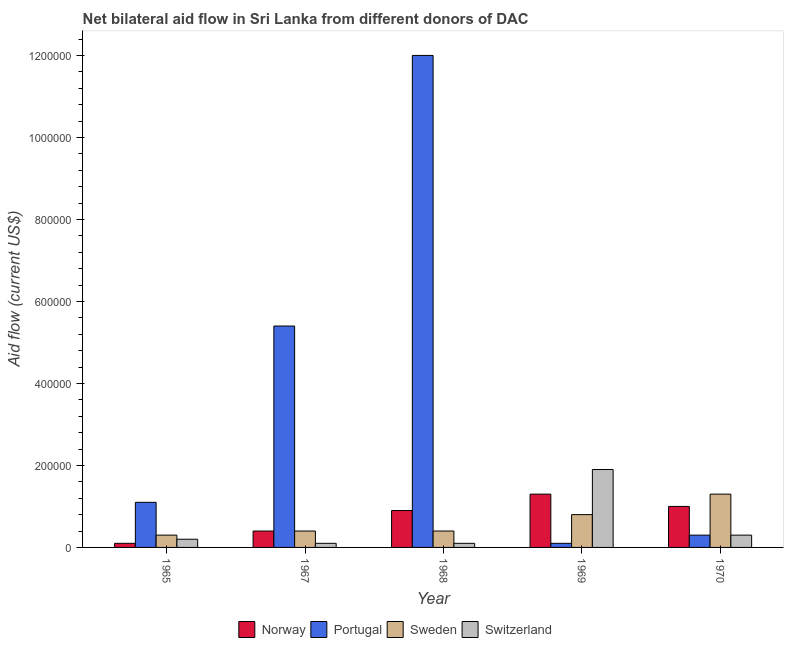How many different coloured bars are there?
Offer a terse response. 4. How many groups of bars are there?
Offer a terse response. 5. Are the number of bars on each tick of the X-axis equal?
Ensure brevity in your answer.  Yes. How many bars are there on the 1st tick from the left?
Keep it short and to the point. 4. What is the label of the 3rd group of bars from the left?
Your answer should be compact. 1968. In how many cases, is the number of bars for a given year not equal to the number of legend labels?
Give a very brief answer. 0. What is the amount of aid given by portugal in 1969?
Your response must be concise. 10000. Across all years, what is the maximum amount of aid given by norway?
Make the answer very short. 1.30e+05. Across all years, what is the minimum amount of aid given by switzerland?
Keep it short and to the point. 10000. In which year was the amount of aid given by switzerland maximum?
Keep it short and to the point. 1969. In which year was the amount of aid given by sweden minimum?
Provide a short and direct response. 1965. What is the total amount of aid given by portugal in the graph?
Make the answer very short. 1.89e+06. What is the difference between the amount of aid given by switzerland in 1965 and that in 1967?
Provide a succinct answer. 10000. What is the difference between the amount of aid given by sweden in 1967 and the amount of aid given by portugal in 1970?
Provide a short and direct response. -9.00e+04. What is the average amount of aid given by portugal per year?
Your answer should be very brief. 3.78e+05. In the year 1965, what is the difference between the amount of aid given by sweden and amount of aid given by switzerland?
Provide a succinct answer. 0. In how many years, is the amount of aid given by sweden greater than 760000 US$?
Offer a very short reply. 0. What is the ratio of the amount of aid given by sweden in 1969 to that in 1970?
Your answer should be very brief. 0.62. Is the amount of aid given by switzerland in 1965 less than that in 1968?
Ensure brevity in your answer.  No. Is the difference between the amount of aid given by norway in 1965 and 1969 greater than the difference between the amount of aid given by switzerland in 1965 and 1969?
Your answer should be compact. No. What is the difference between the highest and the second highest amount of aid given by sweden?
Offer a terse response. 5.00e+04. What is the difference between the highest and the lowest amount of aid given by norway?
Provide a short and direct response. 1.20e+05. In how many years, is the amount of aid given by portugal greater than the average amount of aid given by portugal taken over all years?
Your response must be concise. 2. Is the sum of the amount of aid given by portugal in 1967 and 1969 greater than the maximum amount of aid given by norway across all years?
Provide a succinct answer. No. Is it the case that in every year, the sum of the amount of aid given by norway and amount of aid given by portugal is greater than the sum of amount of aid given by switzerland and amount of aid given by sweden?
Provide a short and direct response. No. Is it the case that in every year, the sum of the amount of aid given by norway and amount of aid given by portugal is greater than the amount of aid given by sweden?
Your answer should be compact. No. How many bars are there?
Your answer should be compact. 20. Are all the bars in the graph horizontal?
Your answer should be very brief. No. How many years are there in the graph?
Your answer should be very brief. 5. Where does the legend appear in the graph?
Ensure brevity in your answer.  Bottom center. How many legend labels are there?
Provide a succinct answer. 4. How are the legend labels stacked?
Keep it short and to the point. Horizontal. What is the title of the graph?
Your answer should be very brief. Net bilateral aid flow in Sri Lanka from different donors of DAC. What is the label or title of the X-axis?
Make the answer very short. Year. What is the Aid flow (current US$) in Norway in 1965?
Ensure brevity in your answer.  10000. What is the Aid flow (current US$) of Portugal in 1965?
Your response must be concise. 1.10e+05. What is the Aid flow (current US$) of Sweden in 1965?
Provide a succinct answer. 3.00e+04. What is the Aid flow (current US$) in Portugal in 1967?
Your answer should be compact. 5.40e+05. What is the Aid flow (current US$) in Sweden in 1967?
Keep it short and to the point. 4.00e+04. What is the Aid flow (current US$) of Switzerland in 1967?
Ensure brevity in your answer.  10000. What is the Aid flow (current US$) of Portugal in 1968?
Provide a short and direct response. 1.20e+06. What is the Aid flow (current US$) of Switzerland in 1968?
Your response must be concise. 10000. What is the Aid flow (current US$) in Portugal in 1969?
Provide a succinct answer. 10000. What is the Aid flow (current US$) in Sweden in 1969?
Offer a very short reply. 8.00e+04. What is the Aid flow (current US$) in Sweden in 1970?
Offer a terse response. 1.30e+05. What is the Aid flow (current US$) of Switzerland in 1970?
Offer a very short reply. 3.00e+04. Across all years, what is the maximum Aid flow (current US$) of Norway?
Keep it short and to the point. 1.30e+05. Across all years, what is the maximum Aid flow (current US$) of Portugal?
Your answer should be very brief. 1.20e+06. Across all years, what is the maximum Aid flow (current US$) of Sweden?
Offer a very short reply. 1.30e+05. Across all years, what is the minimum Aid flow (current US$) in Norway?
Your answer should be compact. 10000. Across all years, what is the minimum Aid flow (current US$) of Portugal?
Your answer should be very brief. 10000. Across all years, what is the minimum Aid flow (current US$) in Switzerland?
Provide a short and direct response. 10000. What is the total Aid flow (current US$) of Norway in the graph?
Ensure brevity in your answer.  3.70e+05. What is the total Aid flow (current US$) of Portugal in the graph?
Your response must be concise. 1.89e+06. What is the total Aid flow (current US$) in Switzerland in the graph?
Ensure brevity in your answer.  2.60e+05. What is the difference between the Aid flow (current US$) in Norway in 1965 and that in 1967?
Give a very brief answer. -3.00e+04. What is the difference between the Aid flow (current US$) of Portugal in 1965 and that in 1967?
Ensure brevity in your answer.  -4.30e+05. What is the difference between the Aid flow (current US$) in Portugal in 1965 and that in 1968?
Keep it short and to the point. -1.09e+06. What is the difference between the Aid flow (current US$) in Switzerland in 1965 and that in 1969?
Give a very brief answer. -1.70e+05. What is the difference between the Aid flow (current US$) in Portugal in 1965 and that in 1970?
Keep it short and to the point. 8.00e+04. What is the difference between the Aid flow (current US$) in Sweden in 1965 and that in 1970?
Provide a short and direct response. -1.00e+05. What is the difference between the Aid flow (current US$) of Switzerland in 1965 and that in 1970?
Your answer should be compact. -10000. What is the difference between the Aid flow (current US$) of Portugal in 1967 and that in 1968?
Keep it short and to the point. -6.60e+05. What is the difference between the Aid flow (current US$) of Portugal in 1967 and that in 1969?
Your answer should be very brief. 5.30e+05. What is the difference between the Aid flow (current US$) in Norway in 1967 and that in 1970?
Keep it short and to the point. -6.00e+04. What is the difference between the Aid flow (current US$) in Portugal in 1967 and that in 1970?
Your answer should be compact. 5.10e+05. What is the difference between the Aid flow (current US$) of Norway in 1968 and that in 1969?
Your response must be concise. -4.00e+04. What is the difference between the Aid flow (current US$) in Portugal in 1968 and that in 1969?
Keep it short and to the point. 1.19e+06. What is the difference between the Aid flow (current US$) in Sweden in 1968 and that in 1969?
Give a very brief answer. -4.00e+04. What is the difference between the Aid flow (current US$) of Switzerland in 1968 and that in 1969?
Make the answer very short. -1.80e+05. What is the difference between the Aid flow (current US$) of Norway in 1968 and that in 1970?
Provide a short and direct response. -10000. What is the difference between the Aid flow (current US$) of Portugal in 1968 and that in 1970?
Offer a very short reply. 1.17e+06. What is the difference between the Aid flow (current US$) of Norway in 1969 and that in 1970?
Keep it short and to the point. 3.00e+04. What is the difference between the Aid flow (current US$) of Sweden in 1969 and that in 1970?
Provide a short and direct response. -5.00e+04. What is the difference between the Aid flow (current US$) in Norway in 1965 and the Aid flow (current US$) in Portugal in 1967?
Ensure brevity in your answer.  -5.30e+05. What is the difference between the Aid flow (current US$) of Norway in 1965 and the Aid flow (current US$) of Switzerland in 1967?
Give a very brief answer. 0. What is the difference between the Aid flow (current US$) in Portugal in 1965 and the Aid flow (current US$) in Sweden in 1967?
Offer a terse response. 7.00e+04. What is the difference between the Aid flow (current US$) in Portugal in 1965 and the Aid flow (current US$) in Switzerland in 1967?
Keep it short and to the point. 1.00e+05. What is the difference between the Aid flow (current US$) of Sweden in 1965 and the Aid flow (current US$) of Switzerland in 1967?
Give a very brief answer. 2.00e+04. What is the difference between the Aid flow (current US$) in Norway in 1965 and the Aid flow (current US$) in Portugal in 1968?
Make the answer very short. -1.19e+06. What is the difference between the Aid flow (current US$) of Norway in 1965 and the Aid flow (current US$) of Sweden in 1968?
Your answer should be compact. -3.00e+04. What is the difference between the Aid flow (current US$) of Norway in 1965 and the Aid flow (current US$) of Switzerland in 1968?
Make the answer very short. 0. What is the difference between the Aid flow (current US$) of Portugal in 1965 and the Aid flow (current US$) of Switzerland in 1968?
Give a very brief answer. 1.00e+05. What is the difference between the Aid flow (current US$) of Sweden in 1965 and the Aid flow (current US$) of Switzerland in 1968?
Give a very brief answer. 2.00e+04. What is the difference between the Aid flow (current US$) in Norway in 1965 and the Aid flow (current US$) in Portugal in 1969?
Your answer should be compact. 0. What is the difference between the Aid flow (current US$) in Norway in 1965 and the Aid flow (current US$) in Sweden in 1969?
Your response must be concise. -7.00e+04. What is the difference between the Aid flow (current US$) in Portugal in 1965 and the Aid flow (current US$) in Switzerland in 1969?
Give a very brief answer. -8.00e+04. What is the difference between the Aid flow (current US$) of Sweden in 1965 and the Aid flow (current US$) of Switzerland in 1969?
Provide a succinct answer. -1.60e+05. What is the difference between the Aid flow (current US$) in Norway in 1965 and the Aid flow (current US$) in Sweden in 1970?
Keep it short and to the point. -1.20e+05. What is the difference between the Aid flow (current US$) in Norway in 1965 and the Aid flow (current US$) in Switzerland in 1970?
Offer a very short reply. -2.00e+04. What is the difference between the Aid flow (current US$) of Portugal in 1965 and the Aid flow (current US$) of Sweden in 1970?
Provide a short and direct response. -2.00e+04. What is the difference between the Aid flow (current US$) in Norway in 1967 and the Aid flow (current US$) in Portugal in 1968?
Your answer should be very brief. -1.16e+06. What is the difference between the Aid flow (current US$) of Norway in 1967 and the Aid flow (current US$) of Sweden in 1968?
Your answer should be very brief. 0. What is the difference between the Aid flow (current US$) of Norway in 1967 and the Aid flow (current US$) of Switzerland in 1968?
Ensure brevity in your answer.  3.00e+04. What is the difference between the Aid flow (current US$) in Portugal in 1967 and the Aid flow (current US$) in Sweden in 1968?
Give a very brief answer. 5.00e+05. What is the difference between the Aid flow (current US$) in Portugal in 1967 and the Aid flow (current US$) in Switzerland in 1968?
Make the answer very short. 5.30e+05. What is the difference between the Aid flow (current US$) in Sweden in 1967 and the Aid flow (current US$) in Switzerland in 1968?
Provide a succinct answer. 3.00e+04. What is the difference between the Aid flow (current US$) in Norway in 1967 and the Aid flow (current US$) in Portugal in 1969?
Your answer should be compact. 3.00e+04. What is the difference between the Aid flow (current US$) of Norway in 1967 and the Aid flow (current US$) of Sweden in 1969?
Your answer should be very brief. -4.00e+04. What is the difference between the Aid flow (current US$) of Norway in 1967 and the Aid flow (current US$) of Switzerland in 1969?
Your answer should be compact. -1.50e+05. What is the difference between the Aid flow (current US$) of Portugal in 1967 and the Aid flow (current US$) of Sweden in 1969?
Make the answer very short. 4.60e+05. What is the difference between the Aid flow (current US$) of Sweden in 1967 and the Aid flow (current US$) of Switzerland in 1969?
Make the answer very short. -1.50e+05. What is the difference between the Aid flow (current US$) in Portugal in 1967 and the Aid flow (current US$) in Sweden in 1970?
Ensure brevity in your answer.  4.10e+05. What is the difference between the Aid flow (current US$) of Portugal in 1967 and the Aid flow (current US$) of Switzerland in 1970?
Give a very brief answer. 5.10e+05. What is the difference between the Aid flow (current US$) in Portugal in 1968 and the Aid flow (current US$) in Sweden in 1969?
Provide a short and direct response. 1.12e+06. What is the difference between the Aid flow (current US$) of Portugal in 1968 and the Aid flow (current US$) of Switzerland in 1969?
Your answer should be very brief. 1.01e+06. What is the difference between the Aid flow (current US$) in Sweden in 1968 and the Aid flow (current US$) in Switzerland in 1969?
Your answer should be very brief. -1.50e+05. What is the difference between the Aid flow (current US$) of Norway in 1968 and the Aid flow (current US$) of Portugal in 1970?
Your answer should be compact. 6.00e+04. What is the difference between the Aid flow (current US$) of Norway in 1968 and the Aid flow (current US$) of Sweden in 1970?
Make the answer very short. -4.00e+04. What is the difference between the Aid flow (current US$) of Portugal in 1968 and the Aid flow (current US$) of Sweden in 1970?
Provide a short and direct response. 1.07e+06. What is the difference between the Aid flow (current US$) of Portugal in 1968 and the Aid flow (current US$) of Switzerland in 1970?
Your answer should be compact. 1.17e+06. What is the difference between the Aid flow (current US$) of Norway in 1969 and the Aid flow (current US$) of Sweden in 1970?
Provide a short and direct response. 0. What is the difference between the Aid flow (current US$) of Portugal in 1969 and the Aid flow (current US$) of Switzerland in 1970?
Your answer should be compact. -2.00e+04. What is the average Aid flow (current US$) in Norway per year?
Your answer should be compact. 7.40e+04. What is the average Aid flow (current US$) in Portugal per year?
Give a very brief answer. 3.78e+05. What is the average Aid flow (current US$) in Sweden per year?
Offer a very short reply. 6.40e+04. What is the average Aid flow (current US$) in Switzerland per year?
Provide a succinct answer. 5.20e+04. In the year 1965, what is the difference between the Aid flow (current US$) of Norway and Aid flow (current US$) of Portugal?
Ensure brevity in your answer.  -1.00e+05. In the year 1965, what is the difference between the Aid flow (current US$) of Portugal and Aid flow (current US$) of Switzerland?
Make the answer very short. 9.00e+04. In the year 1967, what is the difference between the Aid flow (current US$) of Norway and Aid flow (current US$) of Portugal?
Offer a very short reply. -5.00e+05. In the year 1967, what is the difference between the Aid flow (current US$) of Norway and Aid flow (current US$) of Switzerland?
Keep it short and to the point. 3.00e+04. In the year 1967, what is the difference between the Aid flow (current US$) in Portugal and Aid flow (current US$) in Switzerland?
Provide a short and direct response. 5.30e+05. In the year 1968, what is the difference between the Aid flow (current US$) of Norway and Aid flow (current US$) of Portugal?
Ensure brevity in your answer.  -1.11e+06. In the year 1968, what is the difference between the Aid flow (current US$) in Norway and Aid flow (current US$) in Sweden?
Your answer should be compact. 5.00e+04. In the year 1968, what is the difference between the Aid flow (current US$) of Norway and Aid flow (current US$) of Switzerland?
Your response must be concise. 8.00e+04. In the year 1968, what is the difference between the Aid flow (current US$) of Portugal and Aid flow (current US$) of Sweden?
Make the answer very short. 1.16e+06. In the year 1968, what is the difference between the Aid flow (current US$) in Portugal and Aid flow (current US$) in Switzerland?
Ensure brevity in your answer.  1.19e+06. In the year 1969, what is the difference between the Aid flow (current US$) in Portugal and Aid flow (current US$) in Sweden?
Your answer should be very brief. -7.00e+04. In the year 1969, what is the difference between the Aid flow (current US$) in Portugal and Aid flow (current US$) in Switzerland?
Your answer should be compact. -1.80e+05. In the year 1969, what is the difference between the Aid flow (current US$) in Sweden and Aid flow (current US$) in Switzerland?
Your answer should be very brief. -1.10e+05. In the year 1970, what is the difference between the Aid flow (current US$) in Norway and Aid flow (current US$) in Portugal?
Your response must be concise. 7.00e+04. In the year 1970, what is the difference between the Aid flow (current US$) of Portugal and Aid flow (current US$) of Switzerland?
Give a very brief answer. 0. In the year 1970, what is the difference between the Aid flow (current US$) in Sweden and Aid flow (current US$) in Switzerland?
Your response must be concise. 1.00e+05. What is the ratio of the Aid flow (current US$) in Norway in 1965 to that in 1967?
Ensure brevity in your answer.  0.25. What is the ratio of the Aid flow (current US$) in Portugal in 1965 to that in 1967?
Offer a terse response. 0.2. What is the ratio of the Aid flow (current US$) of Switzerland in 1965 to that in 1967?
Offer a very short reply. 2. What is the ratio of the Aid flow (current US$) in Norway in 1965 to that in 1968?
Your answer should be very brief. 0.11. What is the ratio of the Aid flow (current US$) of Portugal in 1965 to that in 1968?
Keep it short and to the point. 0.09. What is the ratio of the Aid flow (current US$) in Norway in 1965 to that in 1969?
Offer a terse response. 0.08. What is the ratio of the Aid flow (current US$) in Portugal in 1965 to that in 1969?
Make the answer very short. 11. What is the ratio of the Aid flow (current US$) in Switzerland in 1965 to that in 1969?
Ensure brevity in your answer.  0.11. What is the ratio of the Aid flow (current US$) in Norway in 1965 to that in 1970?
Ensure brevity in your answer.  0.1. What is the ratio of the Aid flow (current US$) of Portugal in 1965 to that in 1970?
Give a very brief answer. 3.67. What is the ratio of the Aid flow (current US$) of Sweden in 1965 to that in 1970?
Your response must be concise. 0.23. What is the ratio of the Aid flow (current US$) of Switzerland in 1965 to that in 1970?
Your answer should be very brief. 0.67. What is the ratio of the Aid flow (current US$) in Norway in 1967 to that in 1968?
Offer a very short reply. 0.44. What is the ratio of the Aid flow (current US$) in Portugal in 1967 to that in 1968?
Provide a short and direct response. 0.45. What is the ratio of the Aid flow (current US$) of Norway in 1967 to that in 1969?
Make the answer very short. 0.31. What is the ratio of the Aid flow (current US$) in Portugal in 1967 to that in 1969?
Your answer should be compact. 54. What is the ratio of the Aid flow (current US$) in Switzerland in 1967 to that in 1969?
Provide a succinct answer. 0.05. What is the ratio of the Aid flow (current US$) in Sweden in 1967 to that in 1970?
Provide a short and direct response. 0.31. What is the ratio of the Aid flow (current US$) in Norway in 1968 to that in 1969?
Provide a short and direct response. 0.69. What is the ratio of the Aid flow (current US$) in Portugal in 1968 to that in 1969?
Your response must be concise. 120. What is the ratio of the Aid flow (current US$) in Switzerland in 1968 to that in 1969?
Provide a succinct answer. 0.05. What is the ratio of the Aid flow (current US$) in Sweden in 1968 to that in 1970?
Your answer should be very brief. 0.31. What is the ratio of the Aid flow (current US$) of Norway in 1969 to that in 1970?
Offer a very short reply. 1.3. What is the ratio of the Aid flow (current US$) of Sweden in 1969 to that in 1970?
Make the answer very short. 0.62. What is the ratio of the Aid flow (current US$) in Switzerland in 1969 to that in 1970?
Provide a succinct answer. 6.33. What is the difference between the highest and the second highest Aid flow (current US$) of Portugal?
Ensure brevity in your answer.  6.60e+05. What is the difference between the highest and the lowest Aid flow (current US$) of Portugal?
Your answer should be very brief. 1.19e+06. What is the difference between the highest and the lowest Aid flow (current US$) in Sweden?
Your answer should be very brief. 1.00e+05. 